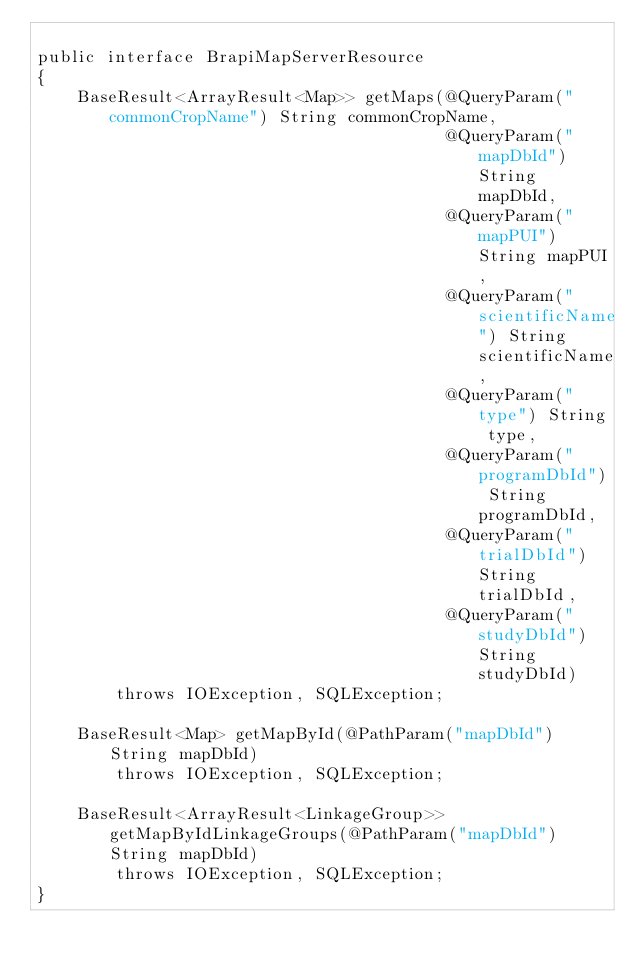Convert code to text. <code><loc_0><loc_0><loc_500><loc_500><_Java_>
public interface BrapiMapServerResource
{
	BaseResult<ArrayResult<Map>> getMaps(@QueryParam("commonCropName") String commonCropName,
										 @QueryParam("mapDbId") String mapDbId,
										 @QueryParam("mapPUI") String mapPUI,
										 @QueryParam("scientificName") String scientificName,
										 @QueryParam("type") String type,
										 @QueryParam("programDbId") String programDbId,
										 @QueryParam("trialDbId") String trialDbId,
										 @QueryParam("studyDbId") String studyDbId)
		throws IOException, SQLException;

	BaseResult<Map> getMapById(@PathParam("mapDbId") String mapDbId)
		throws IOException, SQLException;

	BaseResult<ArrayResult<LinkageGroup>> getMapByIdLinkageGroups(@PathParam("mapDbId") String mapDbId)
		throws IOException, SQLException;
}
</code> 